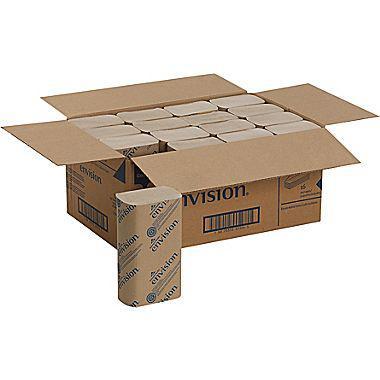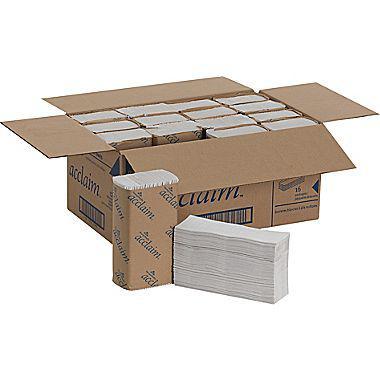The first image is the image on the left, the second image is the image on the right. For the images shown, is this caption "At least one image features one accordion-folded paper towel in front of a stack of folded white paper towels wrapped in printed paper." true? Answer yes or no. No. The first image is the image on the left, the second image is the image on the right. Examine the images to the left and right. Is the description "a single stack of paper towels is wrapped in paper packaging with a single towel next to it" accurate? Answer yes or no. No. 